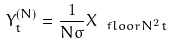Convert formula to latex. <formula><loc_0><loc_0><loc_500><loc_500>Y ^ { ( N ) } _ { t } = \frac { 1 } { N \sigma } X _ { \ f l o o r { N ^ { 2 } t } }</formula> 